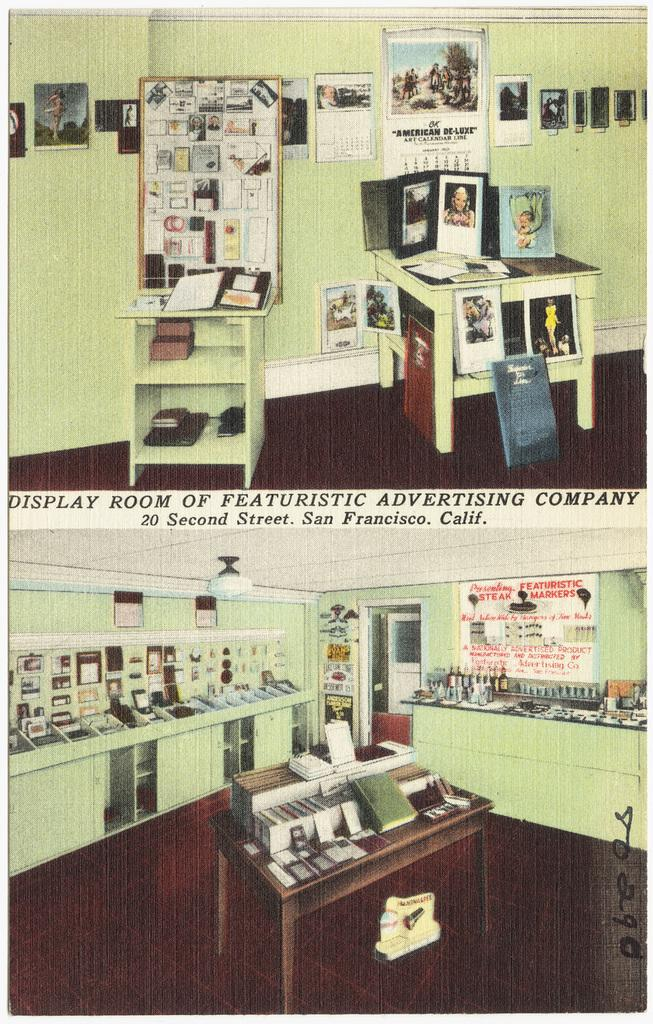What is the main feature of the image? The image contains a collage of two pictures. What types of furniture are present in the collage? There are cupboards, shelves, and tables in the collage. What is placed on the tables in the collage? There are things placed on the tables in the collage. Are there any decorative elements in the collage? Yes, there are frames on the wall in the collage. What type of rod can be seen holding up the snow in the image? There is no rod or snow present in the image; it features a collage of two pictures with furniture and decorative elements. 